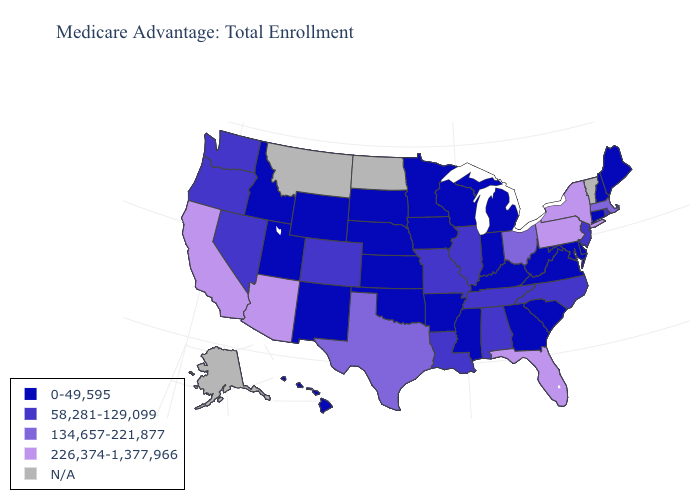Name the states that have a value in the range 0-49,595?
Give a very brief answer. Arkansas, Connecticut, Delaware, Georgia, Hawaii, Iowa, Idaho, Indiana, Kansas, Kentucky, Maryland, Maine, Michigan, Minnesota, Mississippi, Nebraska, New Hampshire, New Mexico, Oklahoma, South Carolina, South Dakota, Utah, Virginia, Wisconsin, West Virginia, Wyoming. Name the states that have a value in the range 134,657-221,877?
Be succinct. Massachusetts, Ohio, Texas. What is the lowest value in states that border Georgia?
Write a very short answer. 0-49,595. Name the states that have a value in the range 134,657-221,877?
Be succinct. Massachusetts, Ohio, Texas. Does Ohio have the highest value in the MidWest?
Give a very brief answer. Yes. What is the value of Utah?
Concise answer only. 0-49,595. What is the value of Washington?
Answer briefly. 58,281-129,099. Which states have the lowest value in the MidWest?
Write a very short answer. Iowa, Indiana, Kansas, Michigan, Minnesota, Nebraska, South Dakota, Wisconsin. Name the states that have a value in the range 58,281-129,099?
Be succinct. Alabama, Colorado, Illinois, Louisiana, Missouri, North Carolina, New Jersey, Nevada, Oregon, Rhode Island, Tennessee, Washington. What is the value of California?
Answer briefly. 226,374-1,377,966. Name the states that have a value in the range N/A?
Concise answer only. Alaska, Montana, North Dakota, Vermont. Among the states that border Virginia , does North Carolina have the lowest value?
Be succinct. No. 